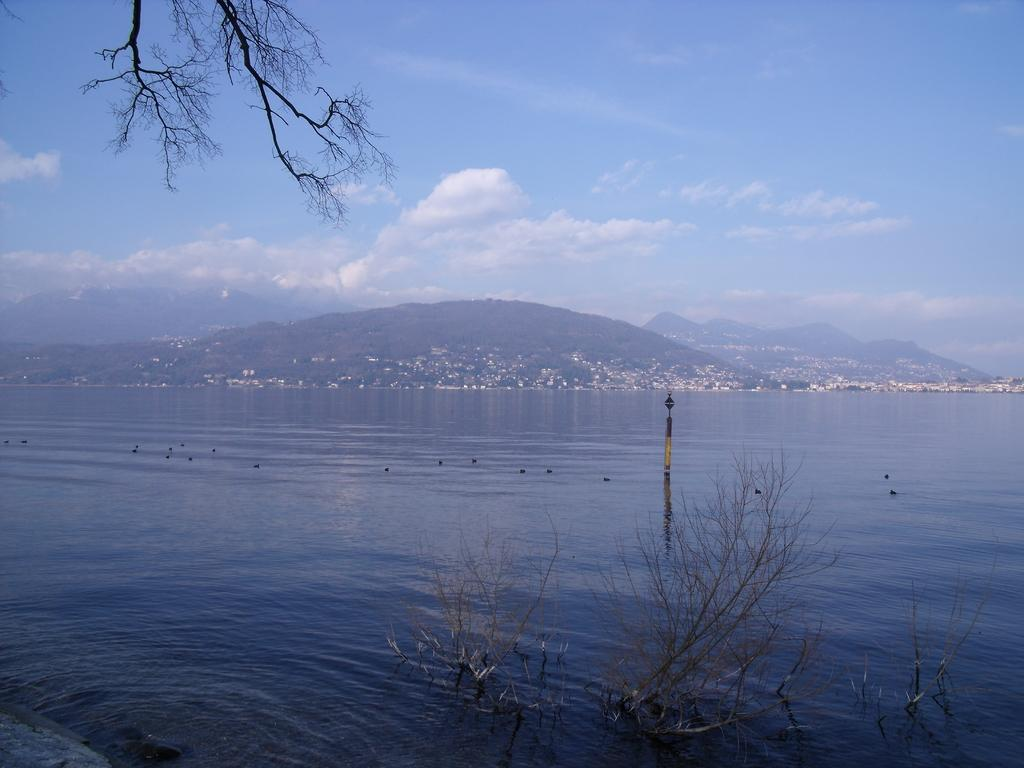What type of natural feature is at the bottom of the image? There is a sea at the bottom of the image. What can be seen in the distance in the image? Hills are visible in the background of the image. What is visible at the top of the image? The sky is visible at the top of the image. What can be observed in the sky? Clouds are present in the sky. What part of a tree is visible in the image? The stems of a tree are visible in the image. What type of bubble is floating in the sea in the image? There is no bubble present in the image; it features a sea, hills, sky, clouds, and tree stems. 